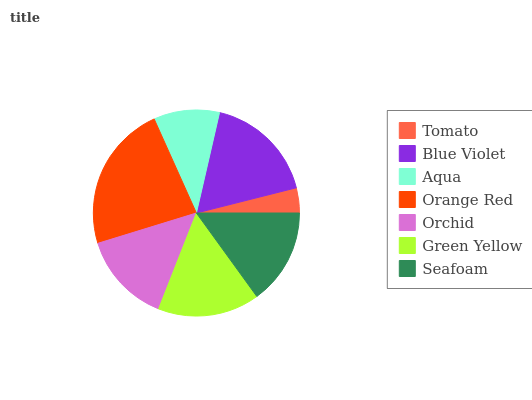Is Tomato the minimum?
Answer yes or no. Yes. Is Orange Red the maximum?
Answer yes or no. Yes. Is Blue Violet the minimum?
Answer yes or no. No. Is Blue Violet the maximum?
Answer yes or no. No. Is Blue Violet greater than Tomato?
Answer yes or no. Yes. Is Tomato less than Blue Violet?
Answer yes or no. Yes. Is Tomato greater than Blue Violet?
Answer yes or no. No. Is Blue Violet less than Tomato?
Answer yes or no. No. Is Seafoam the high median?
Answer yes or no. Yes. Is Seafoam the low median?
Answer yes or no. Yes. Is Orchid the high median?
Answer yes or no. No. Is Orchid the low median?
Answer yes or no. No. 